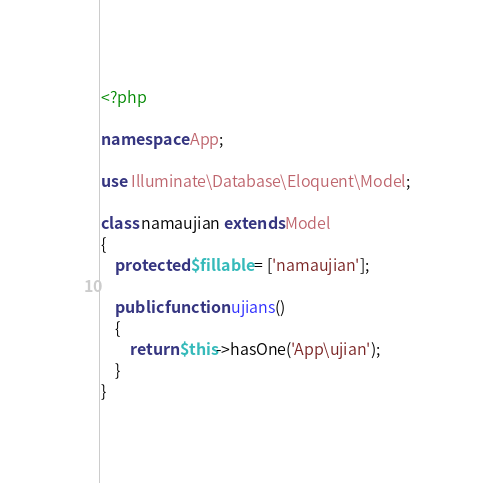Convert code to text. <code><loc_0><loc_0><loc_500><loc_500><_PHP_><?php

namespace App;

use Illuminate\Database\Eloquent\Model;

class namaujian extends Model
{
    protected $fillable = ['namaujian'];

    public function ujians()
    {
        return $this->hasOne('App\ujian');
    }
}
</code> 